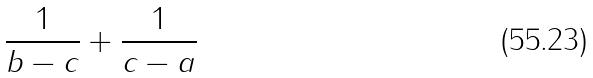<formula> <loc_0><loc_0><loc_500><loc_500>\frac { 1 } { b - c } + \frac { 1 } { c - a }</formula> 